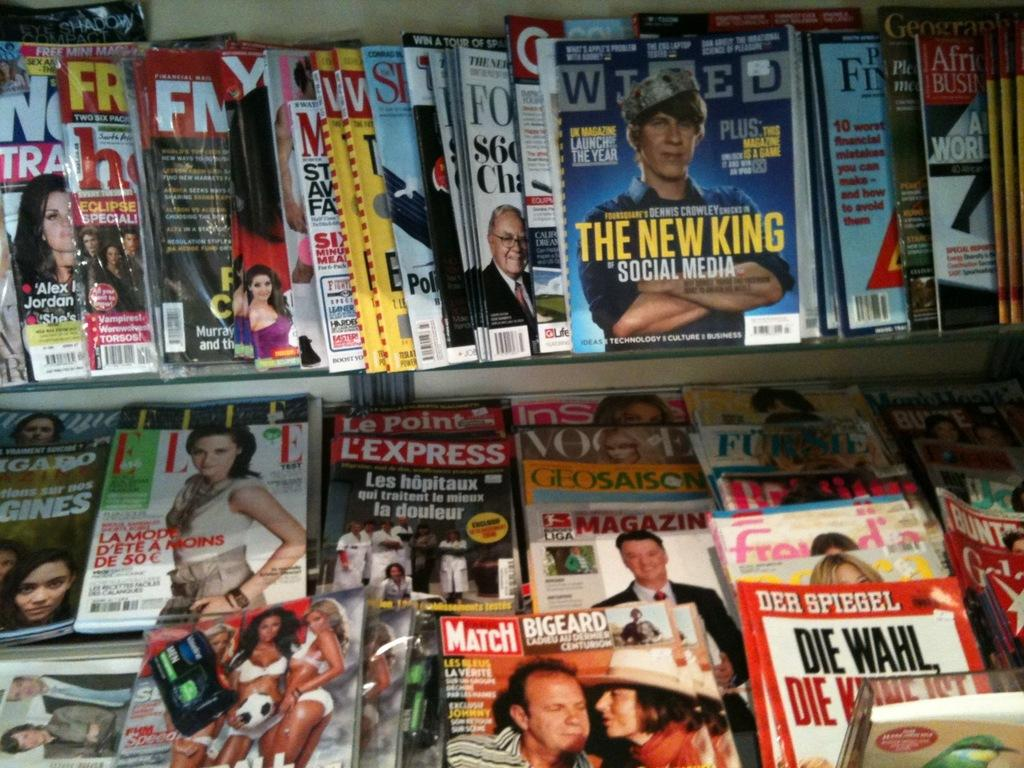<image>
Offer a succinct explanation of the picture presented. a bunch of magazines, one of which is called Match 